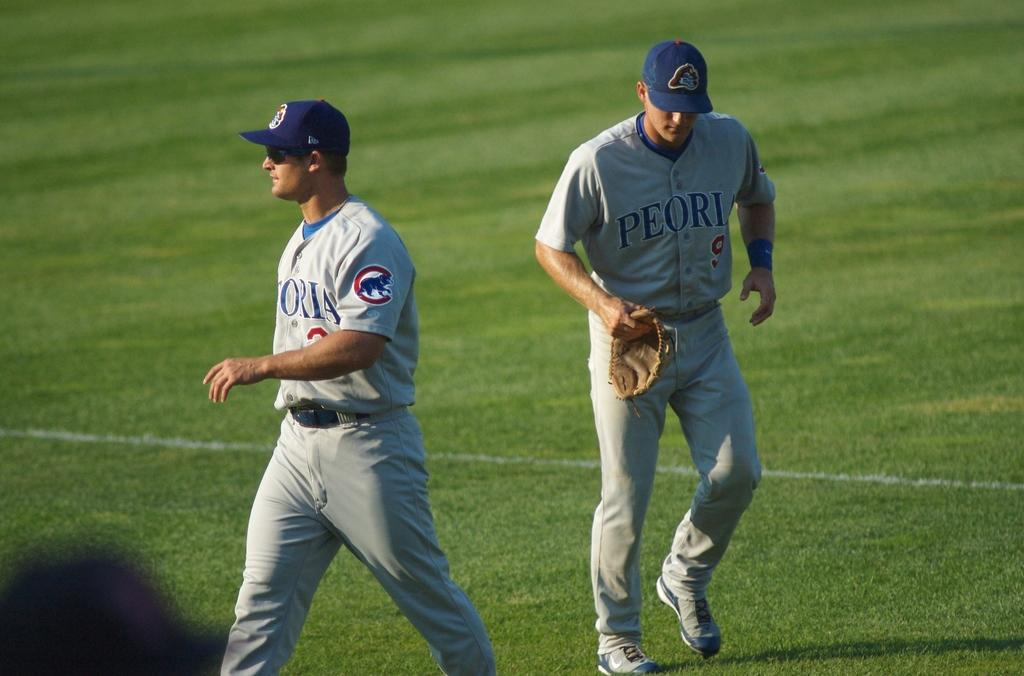Provide a one-sentence caption for the provided image. Two players from the Peoria baseball team on the field of play. 